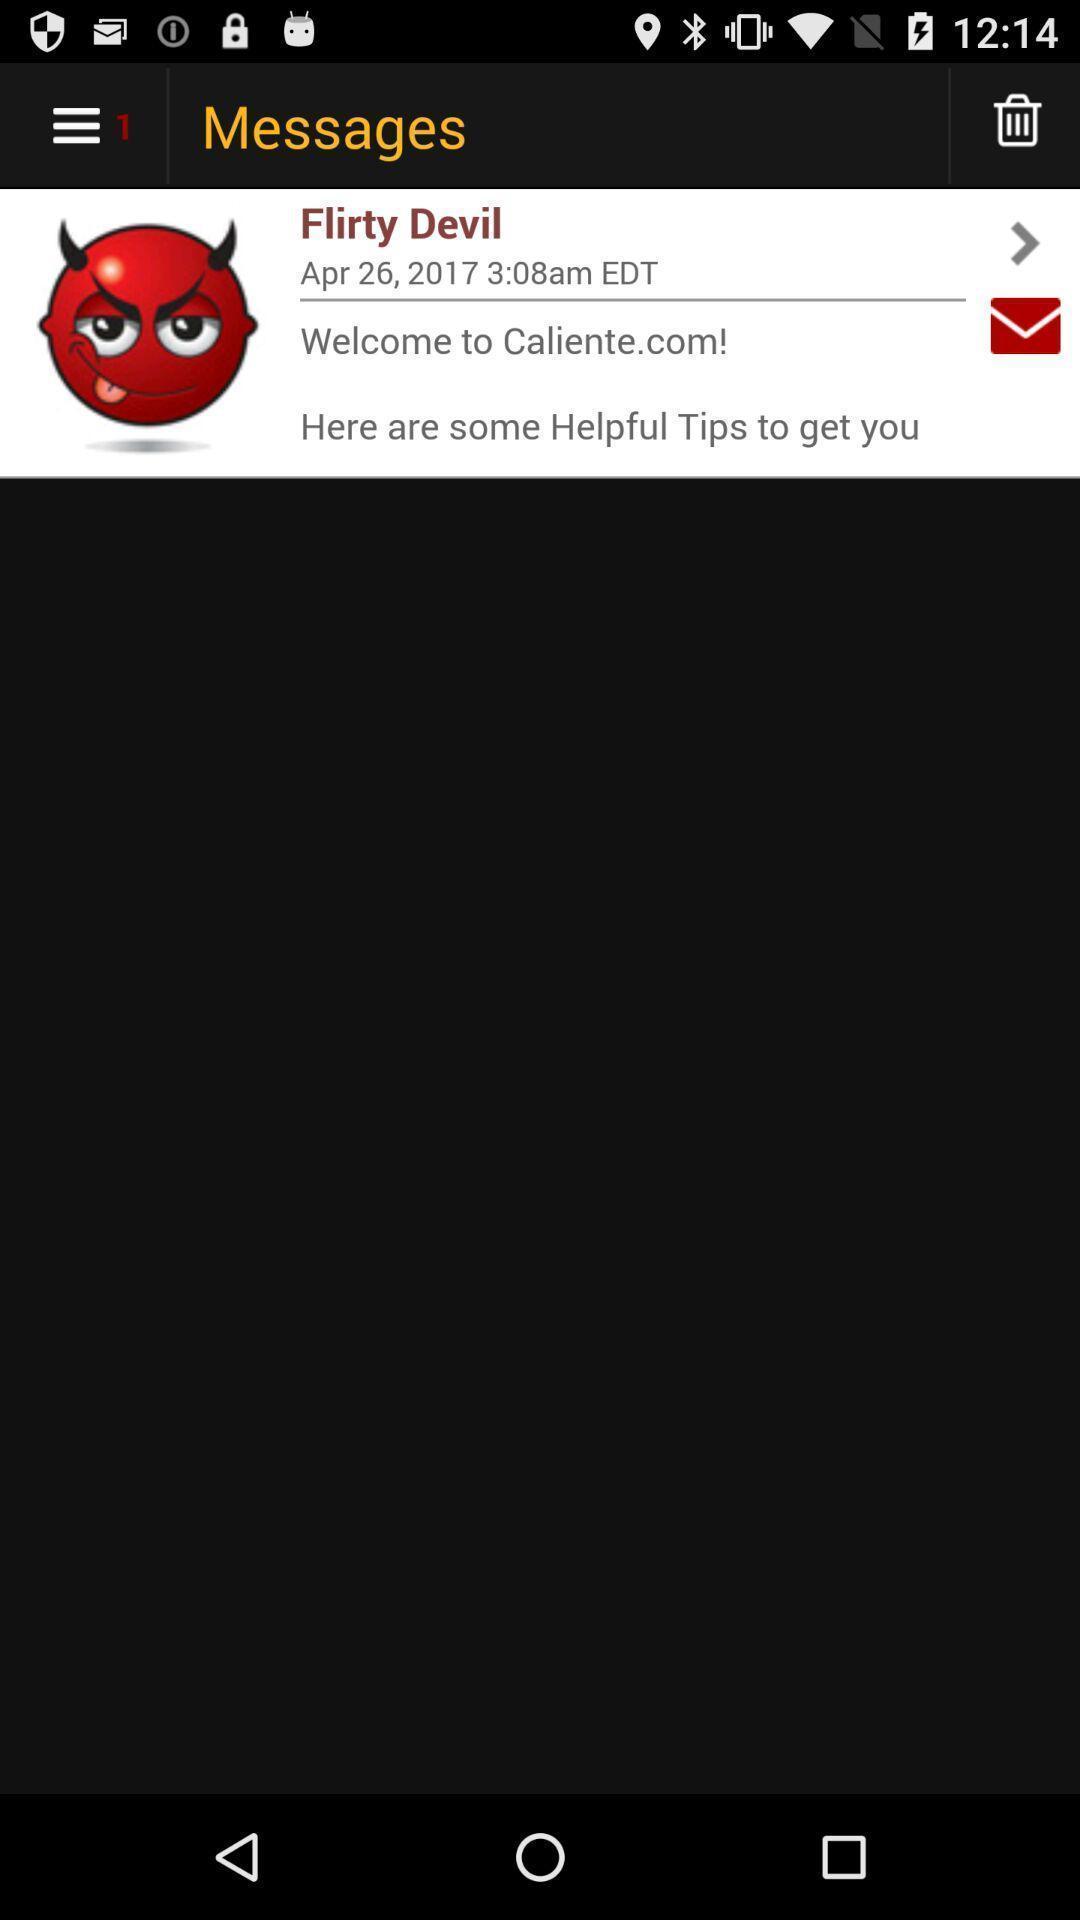Explain what's happening in this screen capture. Welcome page. 